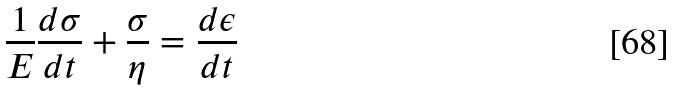Convert formula to latex. <formula><loc_0><loc_0><loc_500><loc_500>\frac { 1 } { E } \frac { d \sigma } { d t } + \frac { \sigma } { \eta } = \frac { d \epsilon } { d t }</formula> 